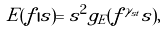Convert formula to latex. <formula><loc_0><loc_0><loc_500><loc_500>E ( f | s ) = s ^ { 2 } g _ { E } ( f ^ { \gamma _ { s t } } s ) ,</formula> 